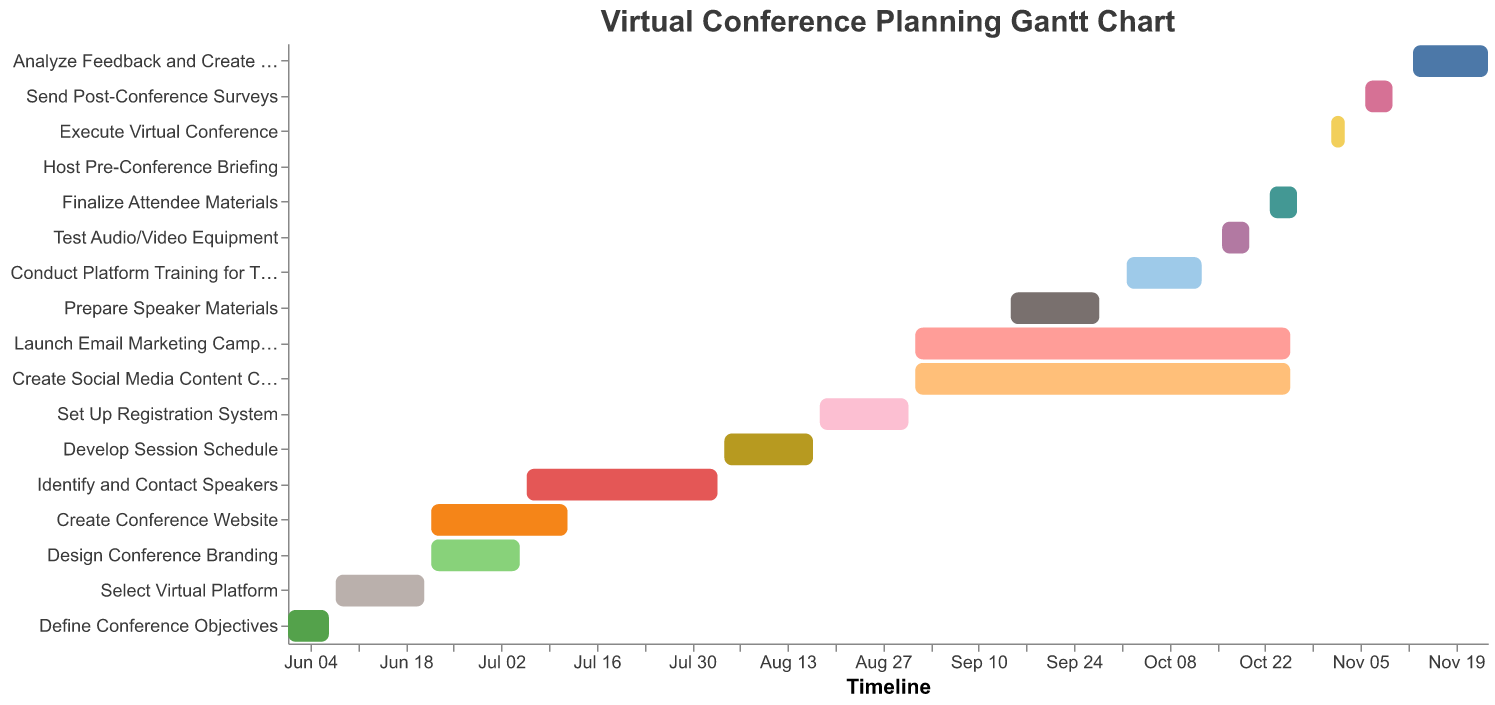How many tasks are listed in the Gantt chart? Count the number of unique tasks mentioned in the chart. There are 17 tasks from "Define Conference Objectives" to "Analyze Feedback and Create Report."
Answer: 17 Which task spans the longest duration? Compare the duration of each task by calculating the difference between the start and end dates. "Launch Email Marketing Campaign" and "Create Social Media Content Calendar" both span from 2023-09-01 to 2023-10-26, which is the longest duration in the chart.
Answer: Launch Email Marketing Campaign, Create Social Media Content Calendar What task is scheduled to start on September 1, 2023? Look for tasks with the start date of "2023-09-01." Both "Launch Email Marketing Campaign" and "Create Social Media Content Calendar" start on this date.
Answer: Launch Email Marketing Campaign, Create Social Media Content Calendar When is the "Execute Virtual Conference" scheduled in the timeline? Check the start and end dates for the task "Execute Virtual Conference." It begins on 2023-11-01 and ends on 2023-11-03.
Answer: November 1 to November 3, 2023 Which tasks are planned to be executed after the "Finalize Attendee Materials"? Identify the end date of "Finalize Attendee Materials" (2023-10-27) and look for tasks starting after this date: "Host Pre-Conference Briefing," "Execute Virtual Conference," "Send Post-Conference Surveys," and "Analyze Feedback and Create Report."
Answer: Host Pre-Conference Briefing, Execute Virtual Conference, Send Post-Conference Surveys, Analyze Feedback and Create Report How many days are allocated to "Identify and Contact Speakers"? Calculate the difference between the start date (2023-07-06) and the end date (2023-08-03). This gives us 28 days.
Answer: 28 Which two tasks overlap the most in terms of time period? Compare overlapping periods of tasks and identify the ones with the longest overlapping duration. "Launch Email Marketing Campaign" and "Create Social Media Content Calendar" both span from 2023-09-01 to 2023-10-26, fully overlapping.
Answer: Launch Email Marketing Campaign and Create Social Media Content Calendar What is the duration between the end of "Prepare Speaker Materials" and the start of "Conduct Platform Training for Team"? Determine the end date of "Prepare Speaker Materials" (2023-09-28) and the start date of "Conduct Platform Training for Team" (2023-10-02). There are 4 days between them.
Answer: 4 days 